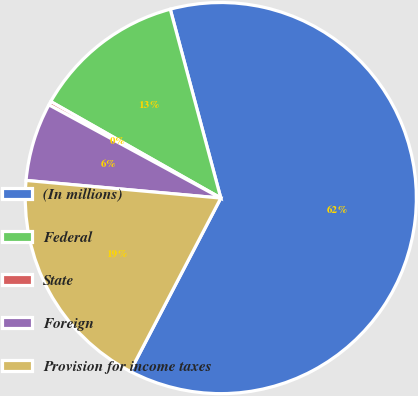<chart> <loc_0><loc_0><loc_500><loc_500><pie_chart><fcel>(In millions)<fcel>Federal<fcel>State<fcel>Foreign<fcel>Provision for income taxes<nl><fcel>61.83%<fcel>12.62%<fcel>0.31%<fcel>6.47%<fcel>18.77%<nl></chart> 